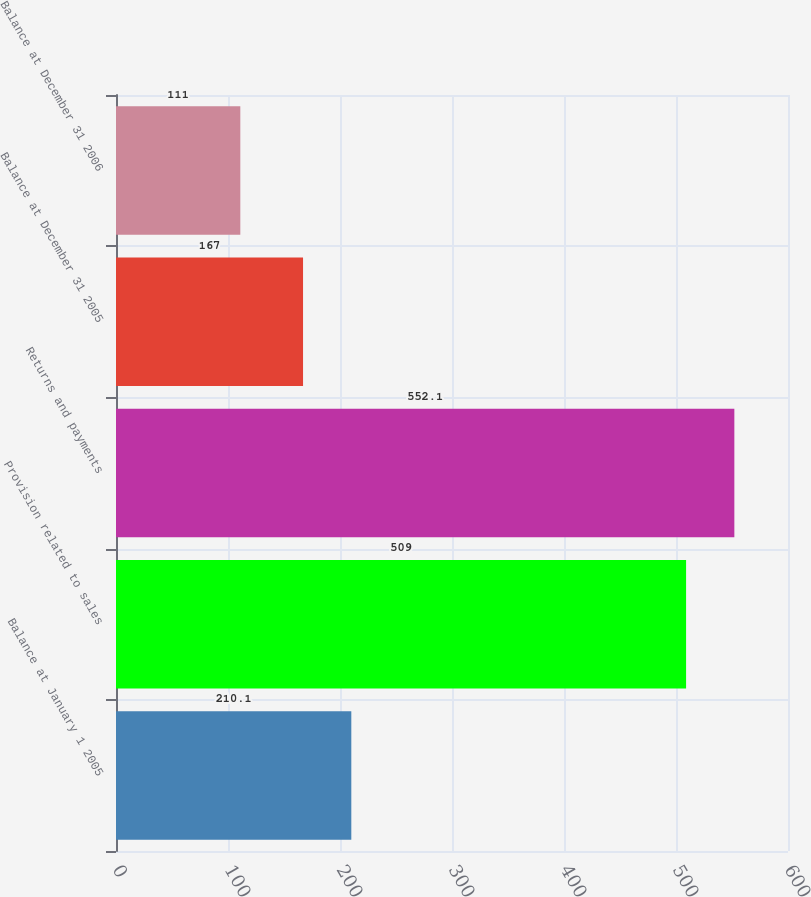Convert chart to OTSL. <chart><loc_0><loc_0><loc_500><loc_500><bar_chart><fcel>Balance at January 1 2005<fcel>Provision related to sales<fcel>Returns and payments<fcel>Balance at December 31 2005<fcel>Balance at December 31 2006<nl><fcel>210.1<fcel>509<fcel>552.1<fcel>167<fcel>111<nl></chart> 